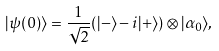<formula> <loc_0><loc_0><loc_500><loc_500>| \psi ( 0 ) \rangle = \frac { 1 } { \sqrt { 2 } } ( | - \rangle - i | + \rangle ) \otimes | \alpha _ { 0 } \rangle ,</formula> 